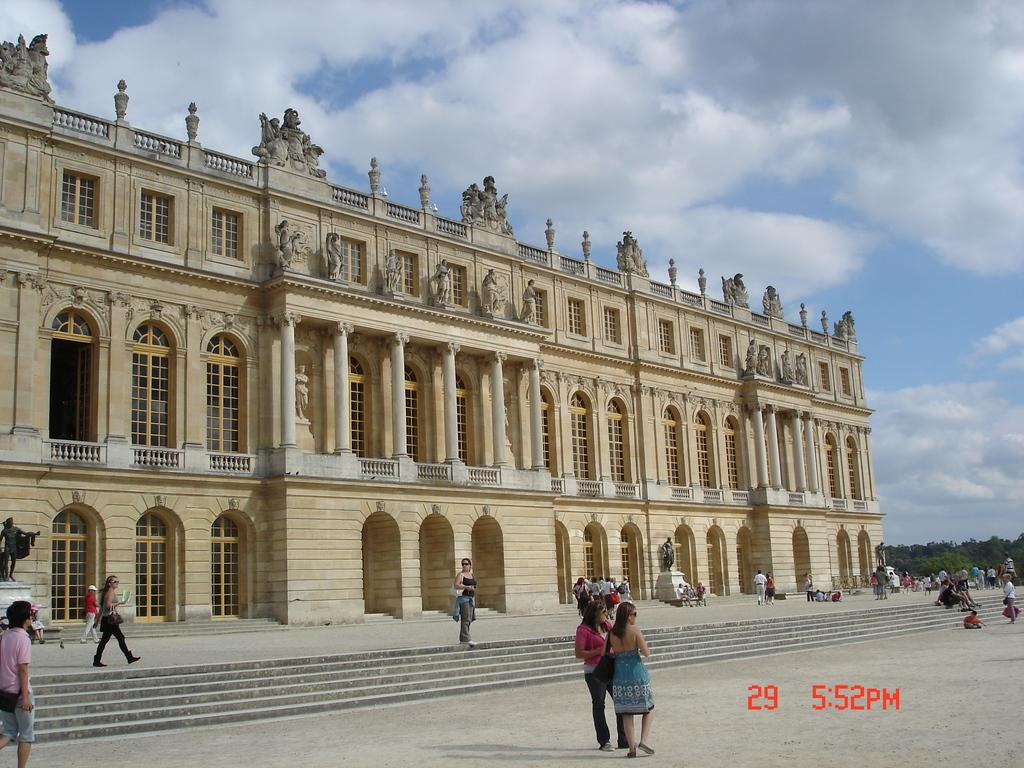What type of structure can be seen in the image? There is a building in the image. What artistic elements are present in the image? There are sculptures in the image. Are there any living beings in the image? Yes, there are people in the image. What type of natural elements can be seen in the image? There are trees in the image. What else can be seen in the image besides the mentioned elements? There are other unspecified things in the image. What is visible in the background of the image? The sky is visible in the background of the image. How does the man's digestion process appear in the image? There is no man present in the image, and therefore no digestion process can be observed. What type of balls are being used in the image? There are no balls present in the image. 